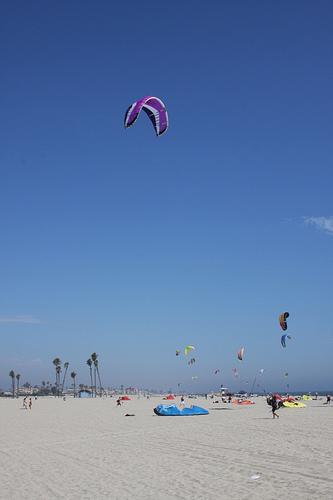What are the chutes for?
Quick response, please. Parasailing. Is the ground covered with snow?
Be succinct. No. How long is the kite's tail?
Short answer required. No tail. Is this beach near a city?
Keep it brief. No. What is in the air?
Quick response, please. Kite. Is it a clear day?
Concise answer only. Yes. What color is the big kite?
Short answer required. Purple. Are there waves?
Give a very brief answer. No. 